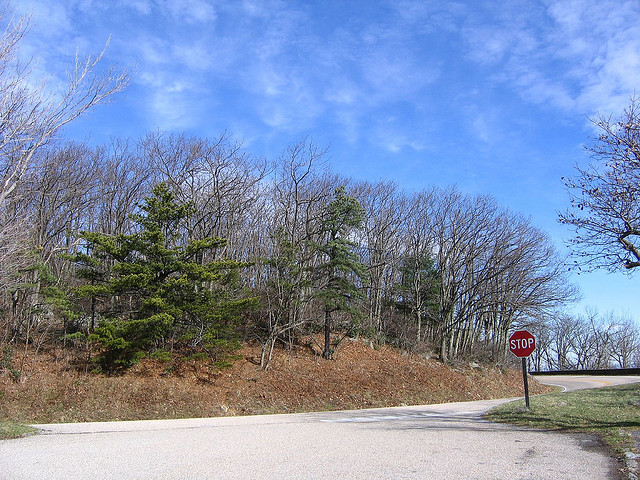<image>What is the name of the photographic effect applied to this image? I don't know what the name of the photographic effect applied to this image. But it may have 'contrast', 'landscape', 'clear', 'filter', 'glazing', 'scenic', 'realism' or 'stop'. Where is the photographer standing? It is ambiguous where the photographer is standing. They could be on the side of the road, at the end of the road, or on the street. Where is the photographer standing? It is ambiguous where the photographer is standing. It can be either on the side of the road or behind something. What is the name of the photographic effect applied to this image? I don't know the name of the photographic effect applied to this image. It could be 'contrast', 'landscape', 'clear', 'none', 'filter', 'glazing', 'scenic', 'realism' or 'stop'. 